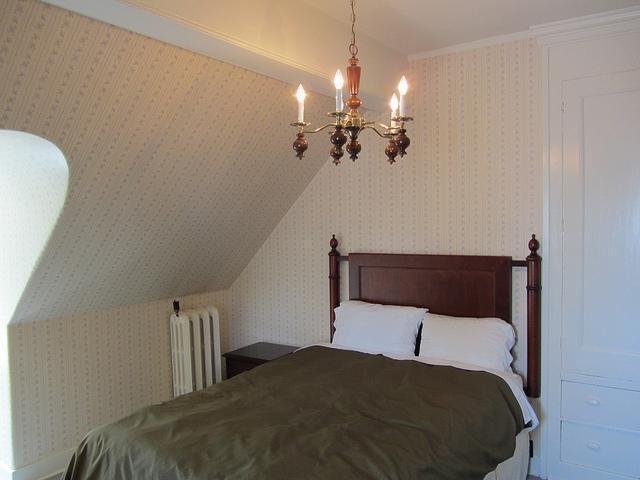How many pillows are there?
Give a very brief answer. 2. How many pillows?
Give a very brief answer. 2. 